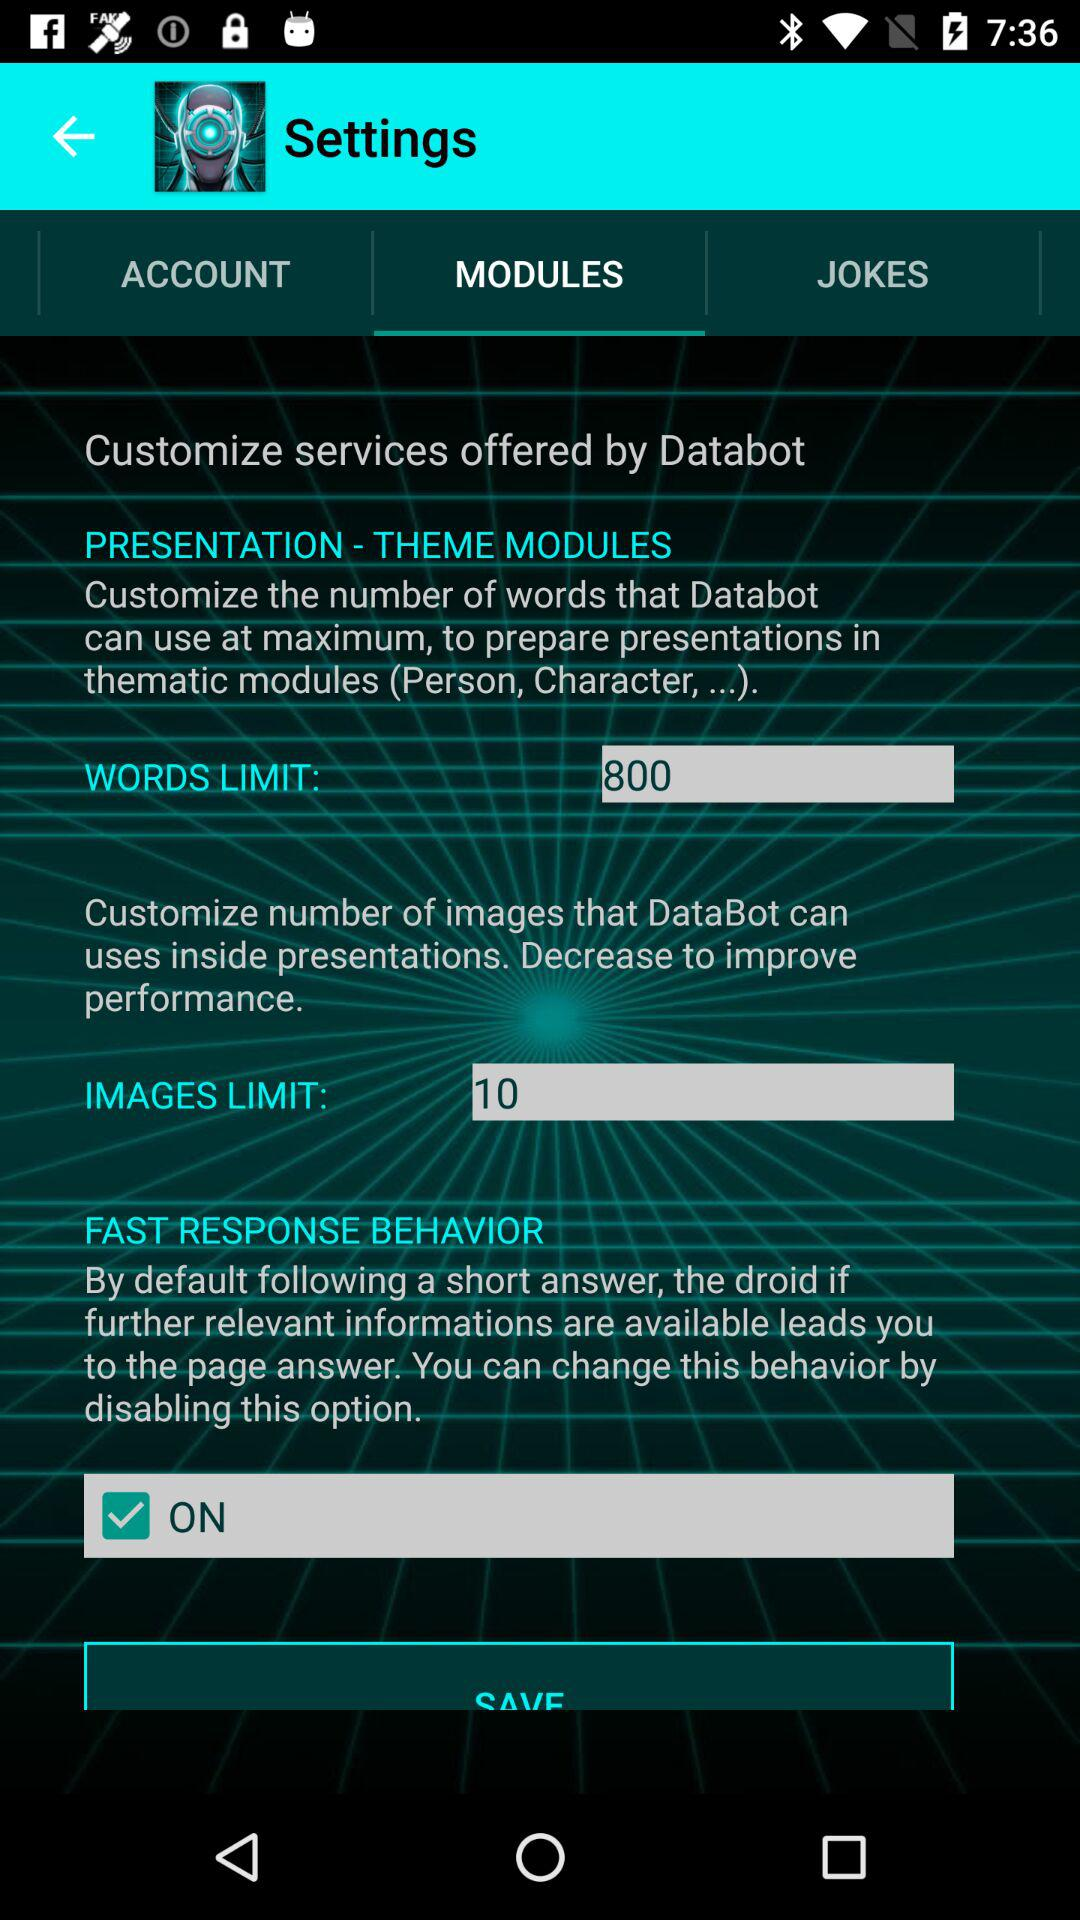Who offers the "Customize services"? "Customize services" are offered by Databot. 